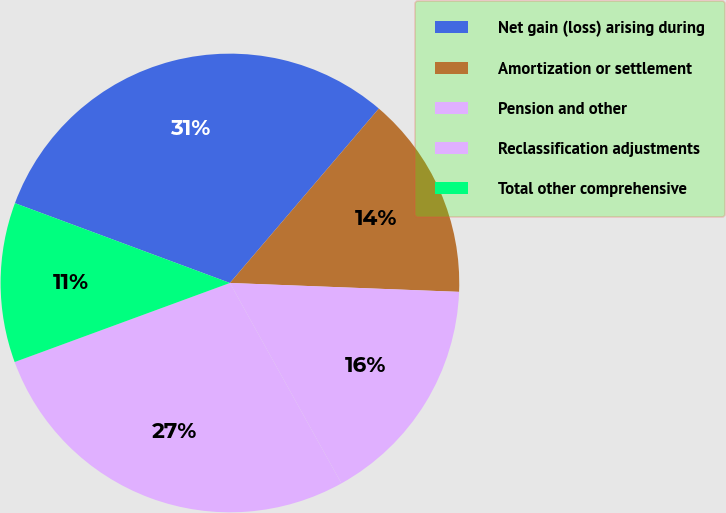Convert chart. <chart><loc_0><loc_0><loc_500><loc_500><pie_chart><fcel>Net gain (loss) arising during<fcel>Amortization or settlement<fcel>Pension and other<fcel>Reclassification adjustments<fcel>Total other comprehensive<nl><fcel>30.59%<fcel>14.37%<fcel>16.3%<fcel>27.48%<fcel>11.26%<nl></chart> 